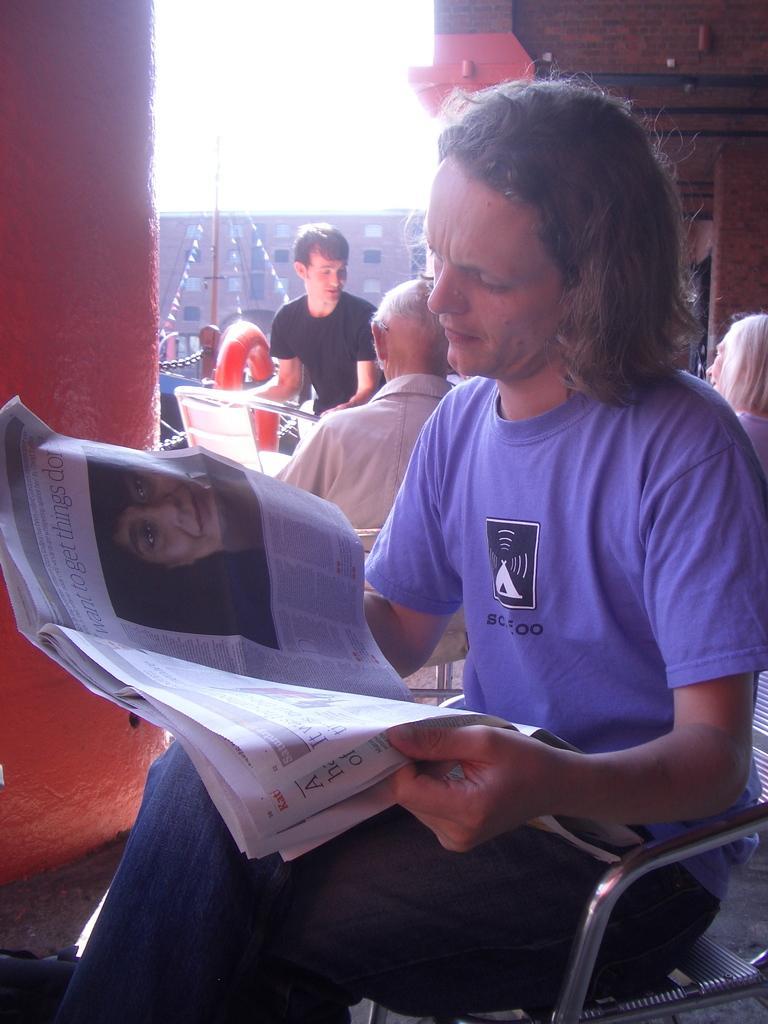In one or two sentences, can you explain what this image depicts? In this image, we can see a person sitting on a chair and holding a newspaper. In the background, we can see people, tube, walls, building, decorative objects, chain, few objects and sky. 